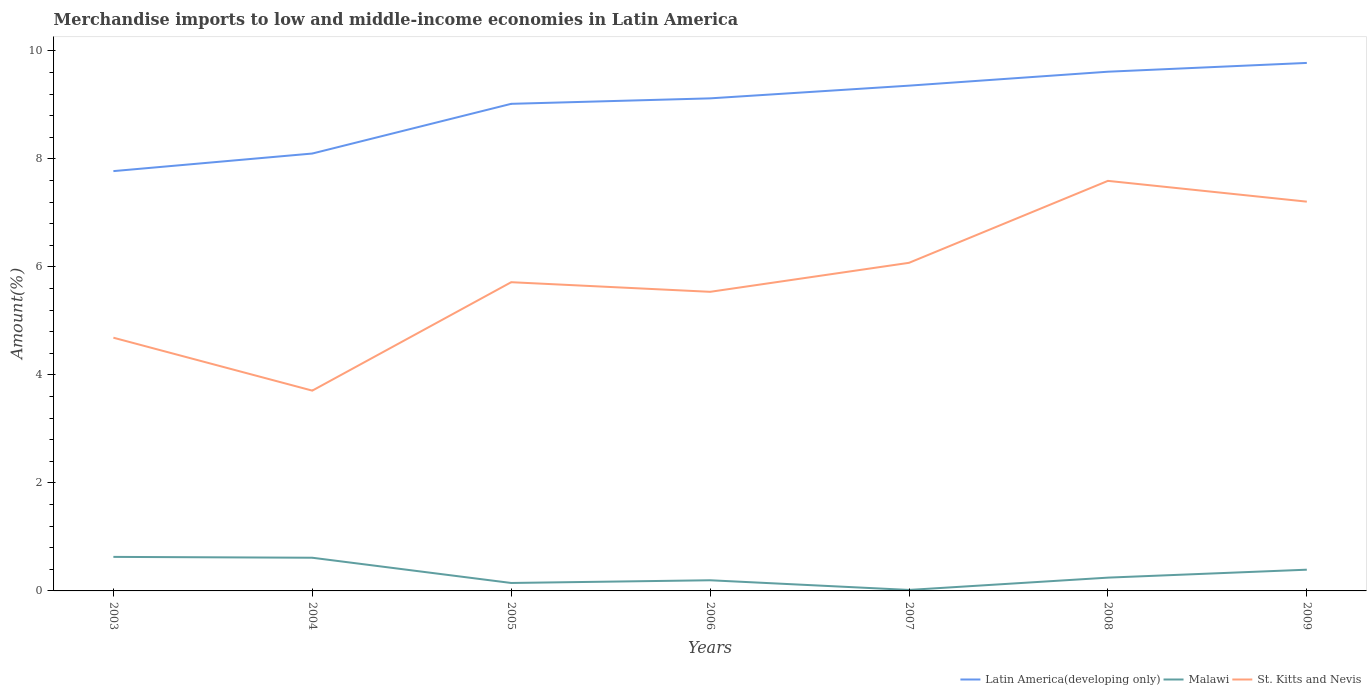Is the number of lines equal to the number of legend labels?
Provide a succinct answer. Yes. Across all years, what is the maximum percentage of amount earned from merchandise imports in Latin America(developing only)?
Provide a succinct answer. 7.77. What is the total percentage of amount earned from merchandise imports in St. Kitts and Nevis in the graph?
Ensure brevity in your answer.  -1.03. What is the difference between the highest and the second highest percentage of amount earned from merchandise imports in Latin America(developing only)?
Give a very brief answer. 2. What is the difference between the highest and the lowest percentage of amount earned from merchandise imports in St. Kitts and Nevis?
Offer a terse response. 3. How many legend labels are there?
Ensure brevity in your answer.  3. How are the legend labels stacked?
Make the answer very short. Horizontal. What is the title of the graph?
Offer a terse response. Merchandise imports to low and middle-income economies in Latin America. What is the label or title of the Y-axis?
Your response must be concise. Amount(%). What is the Amount(%) of Latin America(developing only) in 2003?
Give a very brief answer. 7.77. What is the Amount(%) in Malawi in 2003?
Keep it short and to the point. 0.63. What is the Amount(%) in St. Kitts and Nevis in 2003?
Provide a succinct answer. 4.69. What is the Amount(%) of Latin America(developing only) in 2004?
Give a very brief answer. 8.1. What is the Amount(%) of Malawi in 2004?
Your answer should be very brief. 0.61. What is the Amount(%) in St. Kitts and Nevis in 2004?
Keep it short and to the point. 3.71. What is the Amount(%) in Latin America(developing only) in 2005?
Your response must be concise. 9.02. What is the Amount(%) of Malawi in 2005?
Provide a succinct answer. 0.15. What is the Amount(%) in St. Kitts and Nevis in 2005?
Offer a very short reply. 5.72. What is the Amount(%) of Latin America(developing only) in 2006?
Your answer should be compact. 9.12. What is the Amount(%) of Malawi in 2006?
Give a very brief answer. 0.2. What is the Amount(%) of St. Kitts and Nevis in 2006?
Give a very brief answer. 5.54. What is the Amount(%) of Latin America(developing only) in 2007?
Your answer should be very brief. 9.36. What is the Amount(%) of Malawi in 2007?
Ensure brevity in your answer.  0.02. What is the Amount(%) of St. Kitts and Nevis in 2007?
Your answer should be very brief. 6.08. What is the Amount(%) of Latin America(developing only) in 2008?
Ensure brevity in your answer.  9.61. What is the Amount(%) in Malawi in 2008?
Make the answer very short. 0.25. What is the Amount(%) of St. Kitts and Nevis in 2008?
Offer a terse response. 7.59. What is the Amount(%) of Latin America(developing only) in 2009?
Offer a terse response. 9.78. What is the Amount(%) of Malawi in 2009?
Offer a very short reply. 0.39. What is the Amount(%) of St. Kitts and Nevis in 2009?
Your response must be concise. 7.21. Across all years, what is the maximum Amount(%) of Latin America(developing only)?
Make the answer very short. 9.78. Across all years, what is the maximum Amount(%) in Malawi?
Make the answer very short. 0.63. Across all years, what is the maximum Amount(%) of St. Kitts and Nevis?
Provide a short and direct response. 7.59. Across all years, what is the minimum Amount(%) of Latin America(developing only)?
Give a very brief answer. 7.77. Across all years, what is the minimum Amount(%) in Malawi?
Make the answer very short. 0.02. Across all years, what is the minimum Amount(%) of St. Kitts and Nevis?
Your response must be concise. 3.71. What is the total Amount(%) in Latin America(developing only) in the graph?
Provide a succinct answer. 62.76. What is the total Amount(%) of Malawi in the graph?
Your answer should be very brief. 2.25. What is the total Amount(%) in St. Kitts and Nevis in the graph?
Give a very brief answer. 40.53. What is the difference between the Amount(%) of Latin America(developing only) in 2003 and that in 2004?
Keep it short and to the point. -0.33. What is the difference between the Amount(%) in Malawi in 2003 and that in 2004?
Provide a succinct answer. 0.02. What is the difference between the Amount(%) in St. Kitts and Nevis in 2003 and that in 2004?
Make the answer very short. 0.98. What is the difference between the Amount(%) in Latin America(developing only) in 2003 and that in 2005?
Offer a very short reply. -1.25. What is the difference between the Amount(%) in Malawi in 2003 and that in 2005?
Offer a very short reply. 0.48. What is the difference between the Amount(%) in St. Kitts and Nevis in 2003 and that in 2005?
Make the answer very short. -1.03. What is the difference between the Amount(%) in Latin America(developing only) in 2003 and that in 2006?
Your response must be concise. -1.35. What is the difference between the Amount(%) in Malawi in 2003 and that in 2006?
Offer a terse response. 0.43. What is the difference between the Amount(%) in St. Kitts and Nevis in 2003 and that in 2006?
Provide a succinct answer. -0.85. What is the difference between the Amount(%) in Latin America(developing only) in 2003 and that in 2007?
Keep it short and to the point. -1.58. What is the difference between the Amount(%) of Malawi in 2003 and that in 2007?
Keep it short and to the point. 0.61. What is the difference between the Amount(%) of St. Kitts and Nevis in 2003 and that in 2007?
Your answer should be very brief. -1.39. What is the difference between the Amount(%) in Latin America(developing only) in 2003 and that in 2008?
Your answer should be compact. -1.84. What is the difference between the Amount(%) of Malawi in 2003 and that in 2008?
Your answer should be very brief. 0.38. What is the difference between the Amount(%) in St. Kitts and Nevis in 2003 and that in 2008?
Give a very brief answer. -2.9. What is the difference between the Amount(%) in Latin America(developing only) in 2003 and that in 2009?
Your answer should be very brief. -2. What is the difference between the Amount(%) of Malawi in 2003 and that in 2009?
Provide a short and direct response. 0.24. What is the difference between the Amount(%) in St. Kitts and Nevis in 2003 and that in 2009?
Provide a short and direct response. -2.52. What is the difference between the Amount(%) of Latin America(developing only) in 2004 and that in 2005?
Keep it short and to the point. -0.92. What is the difference between the Amount(%) in Malawi in 2004 and that in 2005?
Your answer should be compact. 0.47. What is the difference between the Amount(%) of St. Kitts and Nevis in 2004 and that in 2005?
Ensure brevity in your answer.  -2.01. What is the difference between the Amount(%) in Latin America(developing only) in 2004 and that in 2006?
Provide a succinct answer. -1.02. What is the difference between the Amount(%) of Malawi in 2004 and that in 2006?
Your response must be concise. 0.42. What is the difference between the Amount(%) in St. Kitts and Nevis in 2004 and that in 2006?
Offer a terse response. -1.83. What is the difference between the Amount(%) of Latin America(developing only) in 2004 and that in 2007?
Ensure brevity in your answer.  -1.26. What is the difference between the Amount(%) of Malawi in 2004 and that in 2007?
Your answer should be very brief. 0.6. What is the difference between the Amount(%) in St. Kitts and Nevis in 2004 and that in 2007?
Offer a very short reply. -2.37. What is the difference between the Amount(%) in Latin America(developing only) in 2004 and that in 2008?
Your response must be concise. -1.52. What is the difference between the Amount(%) in Malawi in 2004 and that in 2008?
Give a very brief answer. 0.37. What is the difference between the Amount(%) of St. Kitts and Nevis in 2004 and that in 2008?
Provide a short and direct response. -3.88. What is the difference between the Amount(%) in Latin America(developing only) in 2004 and that in 2009?
Your response must be concise. -1.68. What is the difference between the Amount(%) of Malawi in 2004 and that in 2009?
Provide a short and direct response. 0.22. What is the difference between the Amount(%) of St. Kitts and Nevis in 2004 and that in 2009?
Make the answer very short. -3.5. What is the difference between the Amount(%) of Latin America(developing only) in 2005 and that in 2006?
Give a very brief answer. -0.1. What is the difference between the Amount(%) of Malawi in 2005 and that in 2006?
Your answer should be compact. -0.05. What is the difference between the Amount(%) in St. Kitts and Nevis in 2005 and that in 2006?
Offer a terse response. 0.18. What is the difference between the Amount(%) of Latin America(developing only) in 2005 and that in 2007?
Offer a very short reply. -0.34. What is the difference between the Amount(%) of Malawi in 2005 and that in 2007?
Your answer should be very brief. 0.13. What is the difference between the Amount(%) of St. Kitts and Nevis in 2005 and that in 2007?
Offer a very short reply. -0.36. What is the difference between the Amount(%) of Latin America(developing only) in 2005 and that in 2008?
Your answer should be very brief. -0.59. What is the difference between the Amount(%) of Malawi in 2005 and that in 2008?
Your answer should be very brief. -0.1. What is the difference between the Amount(%) of St. Kitts and Nevis in 2005 and that in 2008?
Offer a very short reply. -1.88. What is the difference between the Amount(%) in Latin America(developing only) in 2005 and that in 2009?
Your response must be concise. -0.76. What is the difference between the Amount(%) of Malawi in 2005 and that in 2009?
Give a very brief answer. -0.25. What is the difference between the Amount(%) in St. Kitts and Nevis in 2005 and that in 2009?
Provide a short and direct response. -1.49. What is the difference between the Amount(%) in Latin America(developing only) in 2006 and that in 2007?
Provide a short and direct response. -0.24. What is the difference between the Amount(%) in Malawi in 2006 and that in 2007?
Make the answer very short. 0.18. What is the difference between the Amount(%) of St. Kitts and Nevis in 2006 and that in 2007?
Your answer should be compact. -0.54. What is the difference between the Amount(%) of Latin America(developing only) in 2006 and that in 2008?
Your response must be concise. -0.49. What is the difference between the Amount(%) of Malawi in 2006 and that in 2008?
Your answer should be compact. -0.05. What is the difference between the Amount(%) of St. Kitts and Nevis in 2006 and that in 2008?
Your response must be concise. -2.05. What is the difference between the Amount(%) of Latin America(developing only) in 2006 and that in 2009?
Your answer should be very brief. -0.66. What is the difference between the Amount(%) of Malawi in 2006 and that in 2009?
Give a very brief answer. -0.2. What is the difference between the Amount(%) of St. Kitts and Nevis in 2006 and that in 2009?
Ensure brevity in your answer.  -1.67. What is the difference between the Amount(%) of Latin America(developing only) in 2007 and that in 2008?
Provide a succinct answer. -0.26. What is the difference between the Amount(%) of Malawi in 2007 and that in 2008?
Offer a very short reply. -0.23. What is the difference between the Amount(%) in St. Kitts and Nevis in 2007 and that in 2008?
Give a very brief answer. -1.52. What is the difference between the Amount(%) in Latin America(developing only) in 2007 and that in 2009?
Your response must be concise. -0.42. What is the difference between the Amount(%) in Malawi in 2007 and that in 2009?
Make the answer very short. -0.38. What is the difference between the Amount(%) of St. Kitts and Nevis in 2007 and that in 2009?
Give a very brief answer. -1.13. What is the difference between the Amount(%) of Latin America(developing only) in 2008 and that in 2009?
Give a very brief answer. -0.16. What is the difference between the Amount(%) of Malawi in 2008 and that in 2009?
Ensure brevity in your answer.  -0.15. What is the difference between the Amount(%) in St. Kitts and Nevis in 2008 and that in 2009?
Make the answer very short. 0.38. What is the difference between the Amount(%) of Latin America(developing only) in 2003 and the Amount(%) of Malawi in 2004?
Ensure brevity in your answer.  7.16. What is the difference between the Amount(%) of Latin America(developing only) in 2003 and the Amount(%) of St. Kitts and Nevis in 2004?
Make the answer very short. 4.06. What is the difference between the Amount(%) of Malawi in 2003 and the Amount(%) of St. Kitts and Nevis in 2004?
Ensure brevity in your answer.  -3.08. What is the difference between the Amount(%) of Latin America(developing only) in 2003 and the Amount(%) of Malawi in 2005?
Your answer should be compact. 7.63. What is the difference between the Amount(%) in Latin America(developing only) in 2003 and the Amount(%) in St. Kitts and Nevis in 2005?
Give a very brief answer. 2.06. What is the difference between the Amount(%) in Malawi in 2003 and the Amount(%) in St. Kitts and Nevis in 2005?
Your answer should be very brief. -5.09. What is the difference between the Amount(%) in Latin America(developing only) in 2003 and the Amount(%) in Malawi in 2006?
Give a very brief answer. 7.58. What is the difference between the Amount(%) in Latin America(developing only) in 2003 and the Amount(%) in St. Kitts and Nevis in 2006?
Offer a terse response. 2.24. What is the difference between the Amount(%) of Malawi in 2003 and the Amount(%) of St. Kitts and Nevis in 2006?
Give a very brief answer. -4.91. What is the difference between the Amount(%) in Latin America(developing only) in 2003 and the Amount(%) in Malawi in 2007?
Give a very brief answer. 7.76. What is the difference between the Amount(%) of Latin America(developing only) in 2003 and the Amount(%) of St. Kitts and Nevis in 2007?
Keep it short and to the point. 1.7. What is the difference between the Amount(%) in Malawi in 2003 and the Amount(%) in St. Kitts and Nevis in 2007?
Offer a terse response. -5.45. What is the difference between the Amount(%) of Latin America(developing only) in 2003 and the Amount(%) of Malawi in 2008?
Give a very brief answer. 7.53. What is the difference between the Amount(%) of Latin America(developing only) in 2003 and the Amount(%) of St. Kitts and Nevis in 2008?
Your answer should be compact. 0.18. What is the difference between the Amount(%) in Malawi in 2003 and the Amount(%) in St. Kitts and Nevis in 2008?
Ensure brevity in your answer.  -6.96. What is the difference between the Amount(%) in Latin America(developing only) in 2003 and the Amount(%) in Malawi in 2009?
Provide a short and direct response. 7.38. What is the difference between the Amount(%) in Latin America(developing only) in 2003 and the Amount(%) in St. Kitts and Nevis in 2009?
Make the answer very short. 0.57. What is the difference between the Amount(%) in Malawi in 2003 and the Amount(%) in St. Kitts and Nevis in 2009?
Give a very brief answer. -6.58. What is the difference between the Amount(%) in Latin America(developing only) in 2004 and the Amount(%) in Malawi in 2005?
Your answer should be compact. 7.95. What is the difference between the Amount(%) of Latin America(developing only) in 2004 and the Amount(%) of St. Kitts and Nevis in 2005?
Ensure brevity in your answer.  2.38. What is the difference between the Amount(%) in Malawi in 2004 and the Amount(%) in St. Kitts and Nevis in 2005?
Provide a short and direct response. -5.1. What is the difference between the Amount(%) in Latin America(developing only) in 2004 and the Amount(%) in Malawi in 2006?
Provide a succinct answer. 7.9. What is the difference between the Amount(%) of Latin America(developing only) in 2004 and the Amount(%) of St. Kitts and Nevis in 2006?
Your answer should be very brief. 2.56. What is the difference between the Amount(%) of Malawi in 2004 and the Amount(%) of St. Kitts and Nevis in 2006?
Provide a short and direct response. -4.92. What is the difference between the Amount(%) of Latin America(developing only) in 2004 and the Amount(%) of Malawi in 2007?
Your response must be concise. 8.08. What is the difference between the Amount(%) in Latin America(developing only) in 2004 and the Amount(%) in St. Kitts and Nevis in 2007?
Provide a succinct answer. 2.02. What is the difference between the Amount(%) of Malawi in 2004 and the Amount(%) of St. Kitts and Nevis in 2007?
Your answer should be very brief. -5.46. What is the difference between the Amount(%) in Latin America(developing only) in 2004 and the Amount(%) in Malawi in 2008?
Give a very brief answer. 7.85. What is the difference between the Amount(%) in Latin America(developing only) in 2004 and the Amount(%) in St. Kitts and Nevis in 2008?
Keep it short and to the point. 0.51. What is the difference between the Amount(%) in Malawi in 2004 and the Amount(%) in St. Kitts and Nevis in 2008?
Offer a very short reply. -6.98. What is the difference between the Amount(%) in Latin America(developing only) in 2004 and the Amount(%) in Malawi in 2009?
Your response must be concise. 7.71. What is the difference between the Amount(%) in Latin America(developing only) in 2004 and the Amount(%) in St. Kitts and Nevis in 2009?
Offer a very short reply. 0.89. What is the difference between the Amount(%) of Malawi in 2004 and the Amount(%) of St. Kitts and Nevis in 2009?
Ensure brevity in your answer.  -6.59. What is the difference between the Amount(%) of Latin America(developing only) in 2005 and the Amount(%) of Malawi in 2006?
Your answer should be very brief. 8.82. What is the difference between the Amount(%) in Latin America(developing only) in 2005 and the Amount(%) in St. Kitts and Nevis in 2006?
Your answer should be compact. 3.48. What is the difference between the Amount(%) in Malawi in 2005 and the Amount(%) in St. Kitts and Nevis in 2006?
Offer a terse response. -5.39. What is the difference between the Amount(%) in Latin America(developing only) in 2005 and the Amount(%) in Malawi in 2007?
Provide a succinct answer. 9. What is the difference between the Amount(%) in Latin America(developing only) in 2005 and the Amount(%) in St. Kitts and Nevis in 2007?
Provide a succinct answer. 2.94. What is the difference between the Amount(%) in Malawi in 2005 and the Amount(%) in St. Kitts and Nevis in 2007?
Provide a short and direct response. -5.93. What is the difference between the Amount(%) of Latin America(developing only) in 2005 and the Amount(%) of Malawi in 2008?
Ensure brevity in your answer.  8.77. What is the difference between the Amount(%) of Latin America(developing only) in 2005 and the Amount(%) of St. Kitts and Nevis in 2008?
Make the answer very short. 1.43. What is the difference between the Amount(%) in Malawi in 2005 and the Amount(%) in St. Kitts and Nevis in 2008?
Give a very brief answer. -7.45. What is the difference between the Amount(%) of Latin America(developing only) in 2005 and the Amount(%) of Malawi in 2009?
Ensure brevity in your answer.  8.63. What is the difference between the Amount(%) of Latin America(developing only) in 2005 and the Amount(%) of St. Kitts and Nevis in 2009?
Offer a very short reply. 1.81. What is the difference between the Amount(%) in Malawi in 2005 and the Amount(%) in St. Kitts and Nevis in 2009?
Make the answer very short. -7.06. What is the difference between the Amount(%) of Latin America(developing only) in 2006 and the Amount(%) of Malawi in 2007?
Make the answer very short. 9.1. What is the difference between the Amount(%) of Latin America(developing only) in 2006 and the Amount(%) of St. Kitts and Nevis in 2007?
Provide a succinct answer. 3.05. What is the difference between the Amount(%) in Malawi in 2006 and the Amount(%) in St. Kitts and Nevis in 2007?
Give a very brief answer. -5.88. What is the difference between the Amount(%) of Latin America(developing only) in 2006 and the Amount(%) of Malawi in 2008?
Your response must be concise. 8.88. What is the difference between the Amount(%) of Latin America(developing only) in 2006 and the Amount(%) of St. Kitts and Nevis in 2008?
Keep it short and to the point. 1.53. What is the difference between the Amount(%) of Malawi in 2006 and the Amount(%) of St. Kitts and Nevis in 2008?
Your answer should be compact. -7.4. What is the difference between the Amount(%) in Latin America(developing only) in 2006 and the Amount(%) in Malawi in 2009?
Provide a succinct answer. 8.73. What is the difference between the Amount(%) in Latin America(developing only) in 2006 and the Amount(%) in St. Kitts and Nevis in 2009?
Offer a terse response. 1.91. What is the difference between the Amount(%) in Malawi in 2006 and the Amount(%) in St. Kitts and Nevis in 2009?
Keep it short and to the point. -7.01. What is the difference between the Amount(%) of Latin America(developing only) in 2007 and the Amount(%) of Malawi in 2008?
Give a very brief answer. 9.11. What is the difference between the Amount(%) of Latin America(developing only) in 2007 and the Amount(%) of St. Kitts and Nevis in 2008?
Offer a terse response. 1.76. What is the difference between the Amount(%) in Malawi in 2007 and the Amount(%) in St. Kitts and Nevis in 2008?
Your response must be concise. -7.58. What is the difference between the Amount(%) in Latin America(developing only) in 2007 and the Amount(%) in Malawi in 2009?
Provide a succinct answer. 8.96. What is the difference between the Amount(%) of Latin America(developing only) in 2007 and the Amount(%) of St. Kitts and Nevis in 2009?
Make the answer very short. 2.15. What is the difference between the Amount(%) in Malawi in 2007 and the Amount(%) in St. Kitts and Nevis in 2009?
Offer a very short reply. -7.19. What is the difference between the Amount(%) in Latin America(developing only) in 2008 and the Amount(%) in Malawi in 2009?
Your answer should be compact. 9.22. What is the difference between the Amount(%) in Latin America(developing only) in 2008 and the Amount(%) in St. Kitts and Nevis in 2009?
Give a very brief answer. 2.41. What is the difference between the Amount(%) in Malawi in 2008 and the Amount(%) in St. Kitts and Nevis in 2009?
Your response must be concise. -6.96. What is the average Amount(%) in Latin America(developing only) per year?
Give a very brief answer. 8.97. What is the average Amount(%) in Malawi per year?
Provide a short and direct response. 0.32. What is the average Amount(%) of St. Kitts and Nevis per year?
Your answer should be compact. 5.79. In the year 2003, what is the difference between the Amount(%) in Latin America(developing only) and Amount(%) in Malawi?
Your answer should be compact. 7.14. In the year 2003, what is the difference between the Amount(%) in Latin America(developing only) and Amount(%) in St. Kitts and Nevis?
Provide a short and direct response. 3.08. In the year 2003, what is the difference between the Amount(%) in Malawi and Amount(%) in St. Kitts and Nevis?
Your response must be concise. -4.06. In the year 2004, what is the difference between the Amount(%) of Latin America(developing only) and Amount(%) of Malawi?
Give a very brief answer. 7.49. In the year 2004, what is the difference between the Amount(%) in Latin America(developing only) and Amount(%) in St. Kitts and Nevis?
Ensure brevity in your answer.  4.39. In the year 2004, what is the difference between the Amount(%) in Malawi and Amount(%) in St. Kitts and Nevis?
Keep it short and to the point. -3.09. In the year 2005, what is the difference between the Amount(%) of Latin America(developing only) and Amount(%) of Malawi?
Give a very brief answer. 8.87. In the year 2005, what is the difference between the Amount(%) of Latin America(developing only) and Amount(%) of St. Kitts and Nevis?
Offer a terse response. 3.3. In the year 2005, what is the difference between the Amount(%) in Malawi and Amount(%) in St. Kitts and Nevis?
Ensure brevity in your answer.  -5.57. In the year 2006, what is the difference between the Amount(%) in Latin America(developing only) and Amount(%) in Malawi?
Give a very brief answer. 8.92. In the year 2006, what is the difference between the Amount(%) in Latin America(developing only) and Amount(%) in St. Kitts and Nevis?
Keep it short and to the point. 3.58. In the year 2006, what is the difference between the Amount(%) in Malawi and Amount(%) in St. Kitts and Nevis?
Offer a terse response. -5.34. In the year 2007, what is the difference between the Amount(%) in Latin America(developing only) and Amount(%) in Malawi?
Your response must be concise. 9.34. In the year 2007, what is the difference between the Amount(%) in Latin America(developing only) and Amount(%) in St. Kitts and Nevis?
Provide a short and direct response. 3.28. In the year 2007, what is the difference between the Amount(%) in Malawi and Amount(%) in St. Kitts and Nevis?
Make the answer very short. -6.06. In the year 2008, what is the difference between the Amount(%) in Latin America(developing only) and Amount(%) in Malawi?
Your answer should be very brief. 9.37. In the year 2008, what is the difference between the Amount(%) of Latin America(developing only) and Amount(%) of St. Kitts and Nevis?
Offer a terse response. 2.02. In the year 2008, what is the difference between the Amount(%) of Malawi and Amount(%) of St. Kitts and Nevis?
Your answer should be compact. -7.35. In the year 2009, what is the difference between the Amount(%) in Latin America(developing only) and Amount(%) in Malawi?
Provide a succinct answer. 9.38. In the year 2009, what is the difference between the Amount(%) of Latin America(developing only) and Amount(%) of St. Kitts and Nevis?
Offer a terse response. 2.57. In the year 2009, what is the difference between the Amount(%) in Malawi and Amount(%) in St. Kitts and Nevis?
Your answer should be compact. -6.82. What is the ratio of the Amount(%) of Latin America(developing only) in 2003 to that in 2004?
Provide a short and direct response. 0.96. What is the ratio of the Amount(%) of Malawi in 2003 to that in 2004?
Ensure brevity in your answer.  1.03. What is the ratio of the Amount(%) in St. Kitts and Nevis in 2003 to that in 2004?
Offer a very short reply. 1.26. What is the ratio of the Amount(%) of Latin America(developing only) in 2003 to that in 2005?
Your answer should be very brief. 0.86. What is the ratio of the Amount(%) in Malawi in 2003 to that in 2005?
Offer a very short reply. 4.28. What is the ratio of the Amount(%) in St. Kitts and Nevis in 2003 to that in 2005?
Keep it short and to the point. 0.82. What is the ratio of the Amount(%) in Latin America(developing only) in 2003 to that in 2006?
Make the answer very short. 0.85. What is the ratio of the Amount(%) of Malawi in 2003 to that in 2006?
Keep it short and to the point. 3.19. What is the ratio of the Amount(%) in St. Kitts and Nevis in 2003 to that in 2006?
Ensure brevity in your answer.  0.85. What is the ratio of the Amount(%) of Latin America(developing only) in 2003 to that in 2007?
Your response must be concise. 0.83. What is the ratio of the Amount(%) of Malawi in 2003 to that in 2007?
Offer a terse response. 34.57. What is the ratio of the Amount(%) of St. Kitts and Nevis in 2003 to that in 2007?
Give a very brief answer. 0.77. What is the ratio of the Amount(%) of Latin America(developing only) in 2003 to that in 2008?
Give a very brief answer. 0.81. What is the ratio of the Amount(%) in Malawi in 2003 to that in 2008?
Make the answer very short. 2.56. What is the ratio of the Amount(%) in St. Kitts and Nevis in 2003 to that in 2008?
Give a very brief answer. 0.62. What is the ratio of the Amount(%) in Latin America(developing only) in 2003 to that in 2009?
Ensure brevity in your answer.  0.8. What is the ratio of the Amount(%) of Malawi in 2003 to that in 2009?
Offer a very short reply. 1.6. What is the ratio of the Amount(%) of St. Kitts and Nevis in 2003 to that in 2009?
Your answer should be compact. 0.65. What is the ratio of the Amount(%) in Latin America(developing only) in 2004 to that in 2005?
Offer a very short reply. 0.9. What is the ratio of the Amount(%) in Malawi in 2004 to that in 2005?
Ensure brevity in your answer.  4.17. What is the ratio of the Amount(%) of St. Kitts and Nevis in 2004 to that in 2005?
Provide a succinct answer. 0.65. What is the ratio of the Amount(%) in Latin America(developing only) in 2004 to that in 2006?
Ensure brevity in your answer.  0.89. What is the ratio of the Amount(%) of Malawi in 2004 to that in 2006?
Your answer should be very brief. 3.11. What is the ratio of the Amount(%) in St. Kitts and Nevis in 2004 to that in 2006?
Provide a succinct answer. 0.67. What is the ratio of the Amount(%) in Latin America(developing only) in 2004 to that in 2007?
Ensure brevity in your answer.  0.87. What is the ratio of the Amount(%) in Malawi in 2004 to that in 2007?
Keep it short and to the point. 33.71. What is the ratio of the Amount(%) in St. Kitts and Nevis in 2004 to that in 2007?
Your answer should be compact. 0.61. What is the ratio of the Amount(%) in Latin America(developing only) in 2004 to that in 2008?
Give a very brief answer. 0.84. What is the ratio of the Amount(%) of Malawi in 2004 to that in 2008?
Keep it short and to the point. 2.5. What is the ratio of the Amount(%) in St. Kitts and Nevis in 2004 to that in 2008?
Offer a terse response. 0.49. What is the ratio of the Amount(%) of Latin America(developing only) in 2004 to that in 2009?
Offer a very short reply. 0.83. What is the ratio of the Amount(%) of Malawi in 2004 to that in 2009?
Offer a terse response. 1.56. What is the ratio of the Amount(%) in St. Kitts and Nevis in 2004 to that in 2009?
Your answer should be compact. 0.51. What is the ratio of the Amount(%) of Latin America(developing only) in 2005 to that in 2006?
Your answer should be compact. 0.99. What is the ratio of the Amount(%) in Malawi in 2005 to that in 2006?
Give a very brief answer. 0.75. What is the ratio of the Amount(%) of St. Kitts and Nevis in 2005 to that in 2006?
Your answer should be compact. 1.03. What is the ratio of the Amount(%) in Malawi in 2005 to that in 2007?
Keep it short and to the point. 8.08. What is the ratio of the Amount(%) in St. Kitts and Nevis in 2005 to that in 2007?
Provide a short and direct response. 0.94. What is the ratio of the Amount(%) in Latin America(developing only) in 2005 to that in 2008?
Make the answer very short. 0.94. What is the ratio of the Amount(%) in Malawi in 2005 to that in 2008?
Make the answer very short. 0.6. What is the ratio of the Amount(%) of St. Kitts and Nevis in 2005 to that in 2008?
Provide a succinct answer. 0.75. What is the ratio of the Amount(%) of Latin America(developing only) in 2005 to that in 2009?
Provide a succinct answer. 0.92. What is the ratio of the Amount(%) of Malawi in 2005 to that in 2009?
Keep it short and to the point. 0.37. What is the ratio of the Amount(%) in St. Kitts and Nevis in 2005 to that in 2009?
Your response must be concise. 0.79. What is the ratio of the Amount(%) of Latin America(developing only) in 2006 to that in 2007?
Provide a short and direct response. 0.97. What is the ratio of the Amount(%) of Malawi in 2006 to that in 2007?
Make the answer very short. 10.82. What is the ratio of the Amount(%) in St. Kitts and Nevis in 2006 to that in 2007?
Provide a succinct answer. 0.91. What is the ratio of the Amount(%) in Latin America(developing only) in 2006 to that in 2008?
Keep it short and to the point. 0.95. What is the ratio of the Amount(%) in Malawi in 2006 to that in 2008?
Your answer should be very brief. 0.8. What is the ratio of the Amount(%) of St. Kitts and Nevis in 2006 to that in 2008?
Your answer should be compact. 0.73. What is the ratio of the Amount(%) in Latin America(developing only) in 2006 to that in 2009?
Offer a very short reply. 0.93. What is the ratio of the Amount(%) in Malawi in 2006 to that in 2009?
Provide a short and direct response. 0.5. What is the ratio of the Amount(%) in St. Kitts and Nevis in 2006 to that in 2009?
Your answer should be compact. 0.77. What is the ratio of the Amount(%) in Latin America(developing only) in 2007 to that in 2008?
Provide a succinct answer. 0.97. What is the ratio of the Amount(%) in Malawi in 2007 to that in 2008?
Offer a terse response. 0.07. What is the ratio of the Amount(%) of St. Kitts and Nevis in 2007 to that in 2008?
Make the answer very short. 0.8. What is the ratio of the Amount(%) in Latin America(developing only) in 2007 to that in 2009?
Ensure brevity in your answer.  0.96. What is the ratio of the Amount(%) in Malawi in 2007 to that in 2009?
Ensure brevity in your answer.  0.05. What is the ratio of the Amount(%) of St. Kitts and Nevis in 2007 to that in 2009?
Your response must be concise. 0.84. What is the ratio of the Amount(%) in Latin America(developing only) in 2008 to that in 2009?
Offer a very short reply. 0.98. What is the ratio of the Amount(%) in Malawi in 2008 to that in 2009?
Your response must be concise. 0.63. What is the ratio of the Amount(%) of St. Kitts and Nevis in 2008 to that in 2009?
Your answer should be very brief. 1.05. What is the difference between the highest and the second highest Amount(%) in Latin America(developing only)?
Provide a succinct answer. 0.16. What is the difference between the highest and the second highest Amount(%) of Malawi?
Offer a terse response. 0.02. What is the difference between the highest and the second highest Amount(%) of St. Kitts and Nevis?
Make the answer very short. 0.38. What is the difference between the highest and the lowest Amount(%) of Latin America(developing only)?
Your answer should be compact. 2. What is the difference between the highest and the lowest Amount(%) in Malawi?
Offer a terse response. 0.61. What is the difference between the highest and the lowest Amount(%) in St. Kitts and Nevis?
Provide a short and direct response. 3.88. 